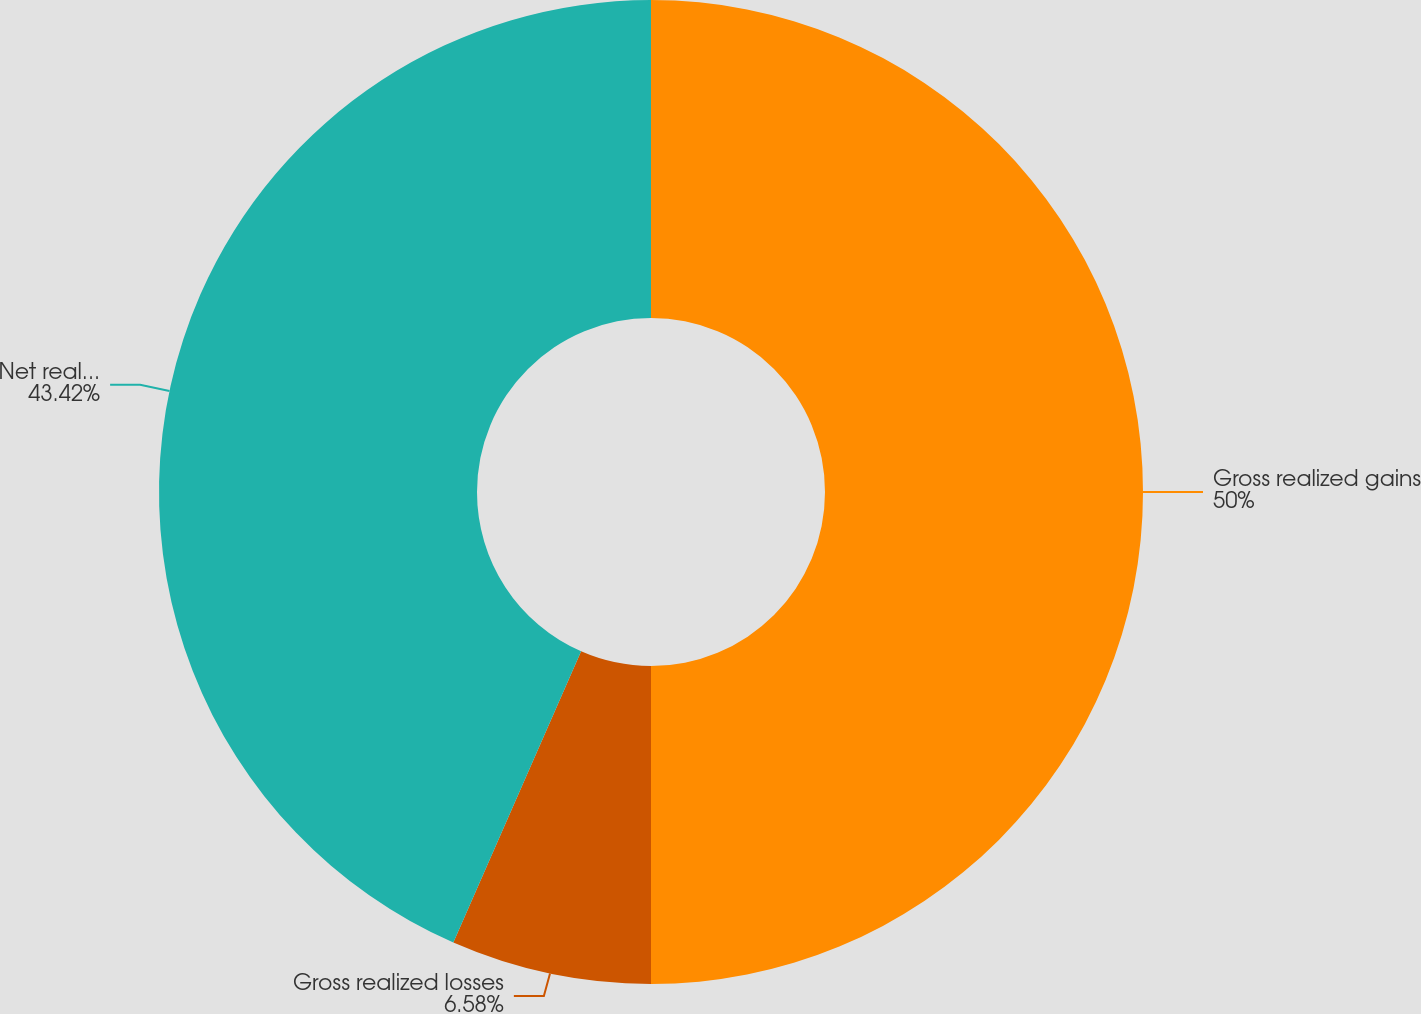Convert chart. <chart><loc_0><loc_0><loc_500><loc_500><pie_chart><fcel>Gross realized gains<fcel>Gross realized losses<fcel>Net realized capital gains<nl><fcel>50.0%<fcel>6.58%<fcel>43.42%<nl></chart> 